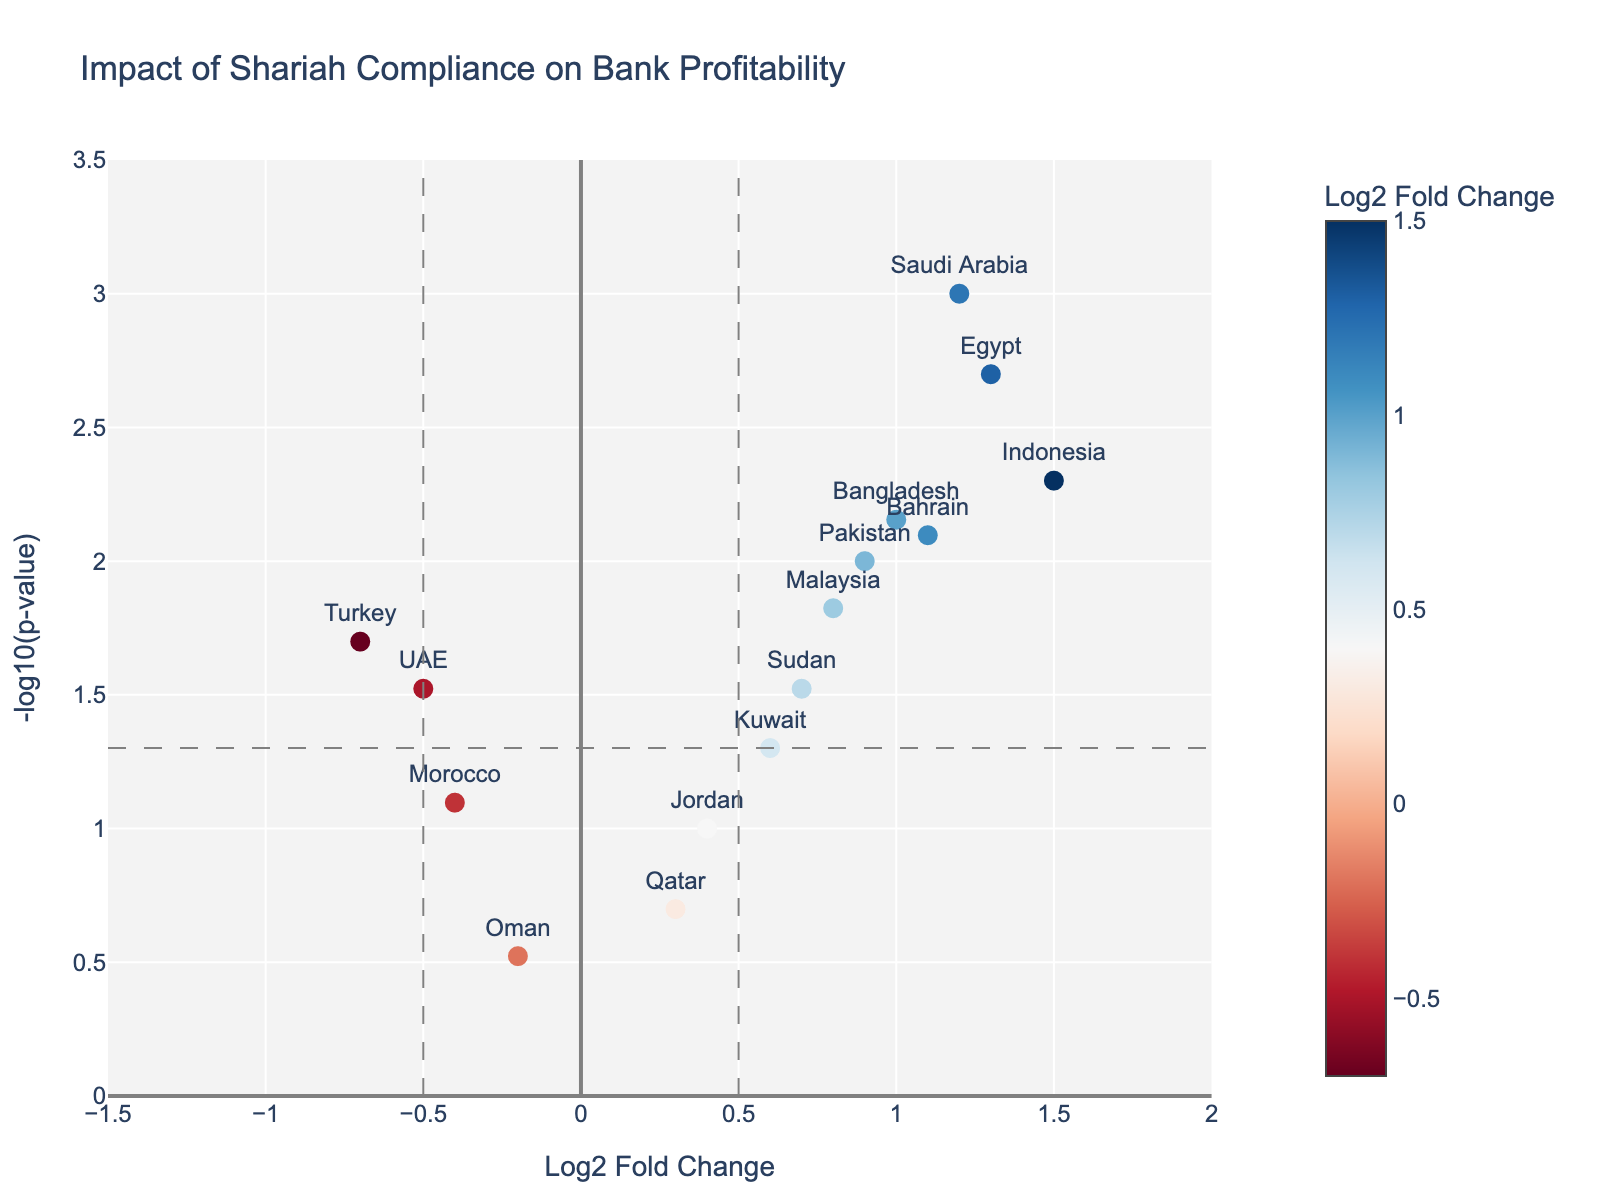What's the title of the figure? The title of the figure is located at the top of the plot.
Answer: Impact of Shariah Compliance on Bank Profitability How many countries have a significant impact on bank profitability (p-value < 0.05)? Look at the scatterplot in the figure; count the data points where the y-value is above the horizontal line representing the significance threshold (p-value = 0.05, i.e., -log10(p-value) = 1.3).
Answer: 11 countries Which country shows the highest positive impact on bank profitability? Identify the data point with the highest x-value (Log2 Fold Change) that also meets the significance criteria (above the horizontal threshold line).
Answer: Indonesia Which country exhibits a significant negative impact on bank profitability? Identify data points with negative x-values (below zero) that are above the significance threshold line. Compare their y-values to find the highest one among them.
Answer: Turkey Which country has a low impact (Log2 Fold Change close to zero) but is still significant? Look for markers around the x-axis value of zero but above the significance threshold line (p-value < 0.05).
Answer: Sudan How many countries are shown to have an insignificant impact on bank profitability (p-value >= 0.05)? Count the data points below the horizontal line representing p=0.05 threshold.
Answer: 4 countries What is the range of Log2 Fold Change values represented in the figure? The Log2 Fold Change is plotted on the x-axis. Identify the minimum and maximum values of the x-axis.
Answer: -1.5 to 2 Which countries are to the left and right of the vertical lines at Log2 Fold Change = -0.5 and 0.5, respectively? Identify the countries located left of the vertical line at -0.5 and right of the vertical line at 0.5 in the scatterplot.
Answer: UAE and Turkey to the left; Saudi Arabia, Malaysia, Indonesia, Qatar, Bahrain, Kuwait, Pakistan, Egypt, Jordan, Bangladesh, Sudan to the right 